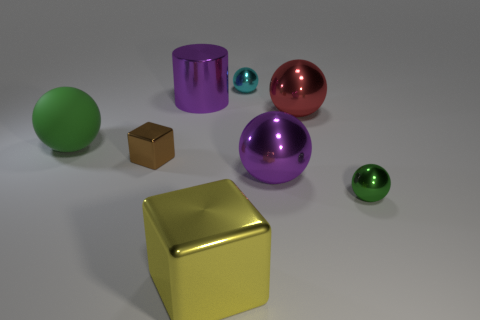What material is the green thing that is to the left of the small metal sphere in front of the tiny metal cube made of?
Ensure brevity in your answer.  Rubber. How many other things are there of the same shape as the small cyan thing?
Provide a short and direct response. 4. There is a large metallic object in front of the tiny green shiny sphere; is its shape the same as the small brown shiny thing that is left of the green shiny object?
Provide a short and direct response. Yes. Is there any other thing that is the same material as the big green object?
Your response must be concise. No. What is the material of the purple ball?
Offer a very short reply. Metal. There is a green ball that is on the right side of the cyan object; what is it made of?
Your answer should be very brief. Metal. Is there anything else that is the same color as the large shiny cylinder?
Keep it short and to the point. Yes. The purple ball that is made of the same material as the big cube is what size?
Make the answer very short. Large. What number of large objects are shiny things or purple cylinders?
Your response must be concise. 4. There is a purple object that is to the right of the purple metal thing that is to the left of the metal cube to the right of the big purple metallic cylinder; how big is it?
Ensure brevity in your answer.  Large. 